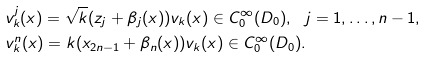Convert formula to latex. <formula><loc_0><loc_0><loc_500><loc_500>& v ^ { j } _ { k } ( x ) = \sqrt { k } ( z _ { j } + \beta _ { j } ( x ) ) v _ { k } ( x ) \in C ^ { \infty } _ { 0 } ( D _ { 0 } ) , \ \ j = 1 , \dots , n - 1 , \\ & v ^ { n } _ { k } ( x ) = k ( x _ { 2 n - 1 } + \beta _ { n } ( x ) ) v _ { k } ( x ) \in C ^ { \infty } _ { 0 } ( D _ { 0 } ) .</formula> 